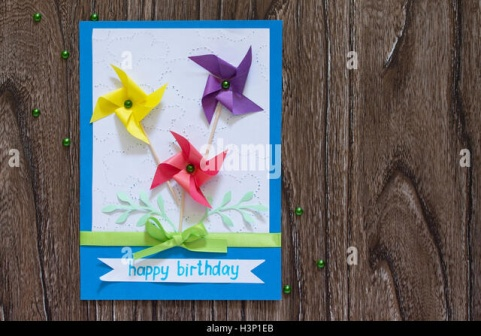What could be the inspiration behind the design elements of this card? The design elements of this card seem to be inspired by playful and celebratory themes. The vibrant colors of the pinwheels—yellow, purple, and red—suggest joy and festivity, reminiscent of childhood toys and carefree moments. The green stems and leaves invoke nature, symbolizing growth and renewal, which might be apt for birthday wishes hoping for a new year full of vitality and happiness. The sparkly green beads scattered around give the impression of a touch of magic or fairy dust, enhancing the whimsical and delightful feel of the card. Additionally, the handwritten-style greeting exudes a personal touch, making it feel more heartfelt and tailored specifically for the recipient. Overall, the design reflects a combination of joy, celebration, and a touch of natural beauty. Imagine this card is part of a gift. What kind of gift would complement it perfectly? A perfect gift to complement this charming handmade birthday card could be something equally thoughtful and personal, such as a handcrafted item or a bespoke gift. For instance, a beautifully decorated box of homemade cookies or a jar of artisanal jams would align well with the card's personal touch. Additionally, a lovingly curated photo album or scrapbook filled with shared memories would enhance the sentimentality conveyed by the card. For a slightly more elaborate option, consider a small potted plant or a bouquet of fresh flowers, echoing the natural and whimsical elements of the card’s design. If the recipient appreciates experiences, a gift such as a voucher for a craft workshop or a creative experience day would also be fitting, encouraging them to create delightful items just like the card itself. 